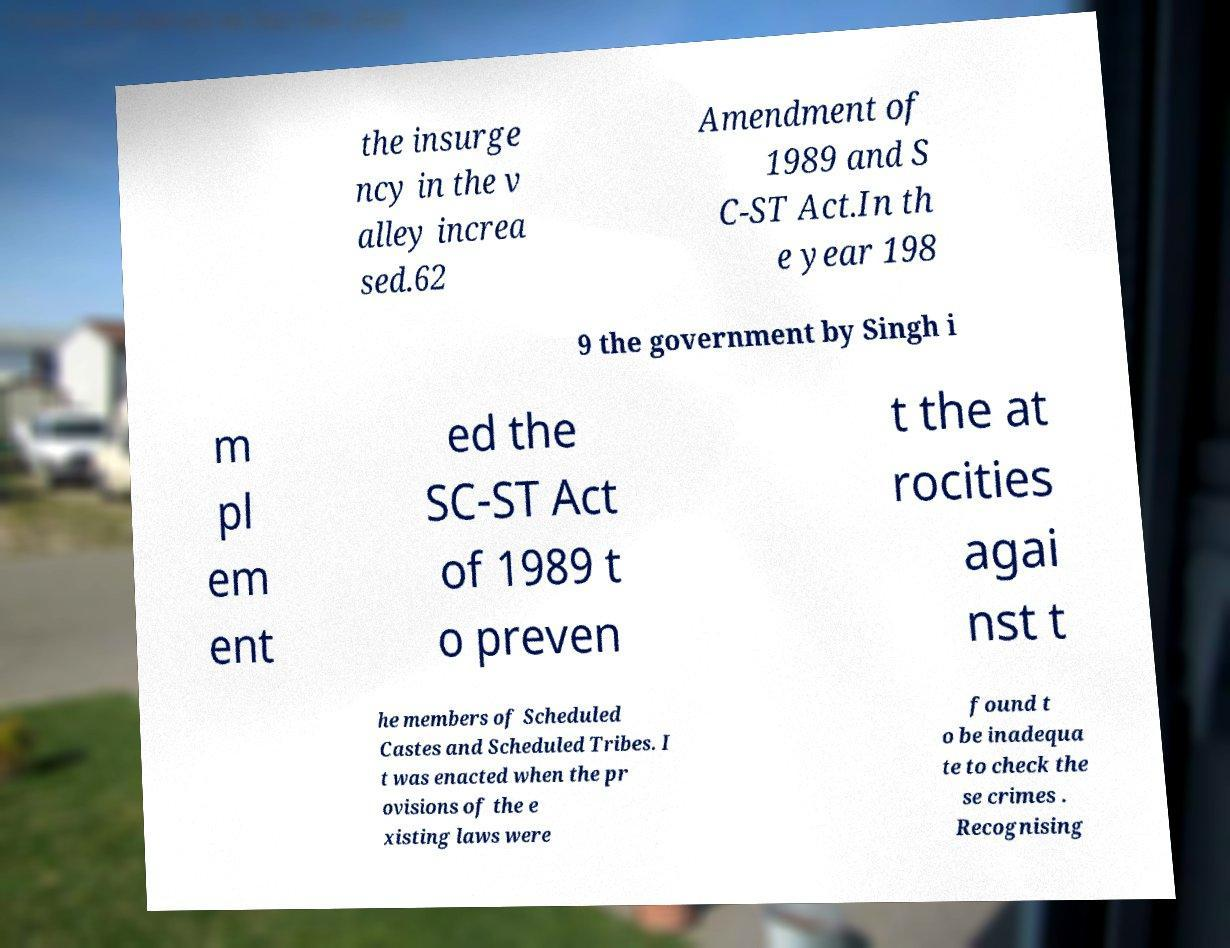Can you read and provide the text displayed in the image?This photo seems to have some interesting text. Can you extract and type it out for me? the insurge ncy in the v alley increa sed.62 Amendment of 1989 and S C-ST Act.In th e year 198 9 the government by Singh i m pl em ent ed the SC-ST Act of 1989 t o preven t the at rocities agai nst t he members of Scheduled Castes and Scheduled Tribes. I t was enacted when the pr ovisions of the e xisting laws were found t o be inadequa te to check the se crimes . Recognising 